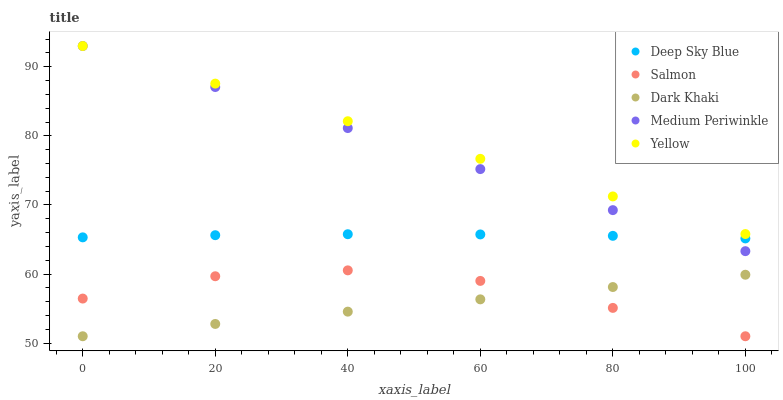Does Dark Khaki have the minimum area under the curve?
Answer yes or no. Yes. Does Yellow have the maximum area under the curve?
Answer yes or no. Yes. Does Medium Periwinkle have the minimum area under the curve?
Answer yes or no. No. Does Medium Periwinkle have the maximum area under the curve?
Answer yes or no. No. Is Dark Khaki the smoothest?
Answer yes or no. Yes. Is Salmon the roughest?
Answer yes or no. Yes. Is Medium Periwinkle the smoothest?
Answer yes or no. No. Is Medium Periwinkle the roughest?
Answer yes or no. No. Does Dark Khaki have the lowest value?
Answer yes or no. Yes. Does Medium Periwinkle have the lowest value?
Answer yes or no. No. Does Yellow have the highest value?
Answer yes or no. Yes. Does Salmon have the highest value?
Answer yes or no. No. Is Dark Khaki less than Medium Periwinkle?
Answer yes or no. Yes. Is Yellow greater than Salmon?
Answer yes or no. Yes. Does Dark Khaki intersect Salmon?
Answer yes or no. Yes. Is Dark Khaki less than Salmon?
Answer yes or no. No. Is Dark Khaki greater than Salmon?
Answer yes or no. No. Does Dark Khaki intersect Medium Periwinkle?
Answer yes or no. No. 